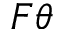<formula> <loc_0><loc_0><loc_500><loc_500>F \theta</formula> 